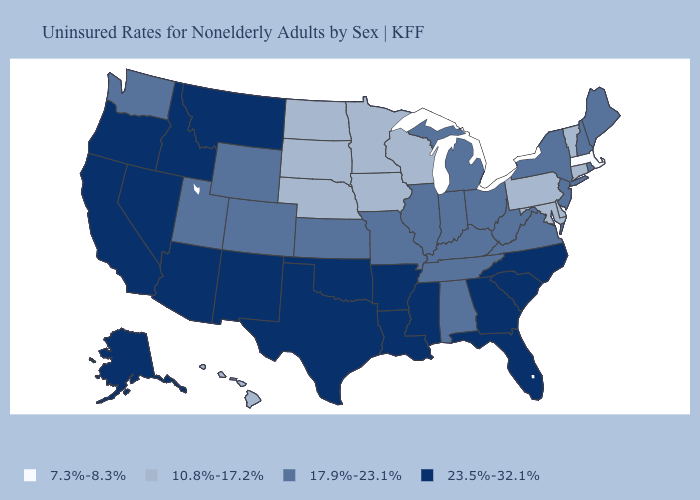What is the value of Washington?
Keep it brief. 17.9%-23.1%. What is the value of North Dakota?
Quick response, please. 10.8%-17.2%. Name the states that have a value in the range 17.9%-23.1%?
Keep it brief. Alabama, Colorado, Illinois, Indiana, Kansas, Kentucky, Maine, Michigan, Missouri, New Hampshire, New Jersey, New York, Ohio, Rhode Island, Tennessee, Utah, Virginia, Washington, West Virginia, Wyoming. Which states have the highest value in the USA?
Concise answer only. Alaska, Arizona, Arkansas, California, Florida, Georgia, Idaho, Louisiana, Mississippi, Montana, Nevada, New Mexico, North Carolina, Oklahoma, Oregon, South Carolina, Texas. Name the states that have a value in the range 7.3%-8.3%?
Short answer required. Massachusetts. Does North Carolina have the lowest value in the USA?
Quick response, please. No. Which states have the lowest value in the South?
Short answer required. Delaware, Maryland. Name the states that have a value in the range 17.9%-23.1%?
Short answer required. Alabama, Colorado, Illinois, Indiana, Kansas, Kentucky, Maine, Michigan, Missouri, New Hampshire, New Jersey, New York, Ohio, Rhode Island, Tennessee, Utah, Virginia, Washington, West Virginia, Wyoming. What is the value of Kansas?
Concise answer only. 17.9%-23.1%. What is the highest value in states that border Illinois?
Be succinct. 17.9%-23.1%. Name the states that have a value in the range 7.3%-8.3%?
Quick response, please. Massachusetts. Which states hav the highest value in the West?
Write a very short answer. Alaska, Arizona, California, Idaho, Montana, Nevada, New Mexico, Oregon. Name the states that have a value in the range 7.3%-8.3%?
Short answer required. Massachusetts. Which states hav the highest value in the Northeast?
Concise answer only. Maine, New Hampshire, New Jersey, New York, Rhode Island. Does the first symbol in the legend represent the smallest category?
Answer briefly. Yes. 